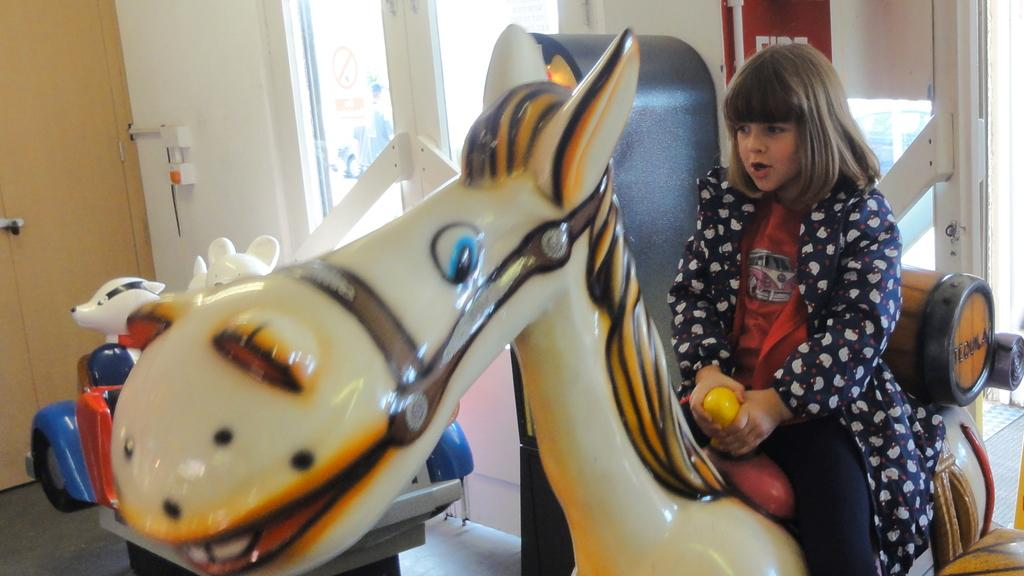Who is in the image? There is a girl in the image. What is the girl sitting on? The girl is sitting on a toy animal. What can be seen through the window in the image? The facts do not specify what can be seen through the window. What type of furniture is present in the image? There is a cupboard in the image. What is the background of the image made of? The background of the image includes a wall. What other objects are present in the image? There are other objects present in the image, but their specific details are not mentioned in the facts. What type of tank is visible in the image? There is no tank present in the image. How does the girl feel while sitting on the toy animal? The facts do not provide information about the girl's feelings, so we cannot answer this question. 